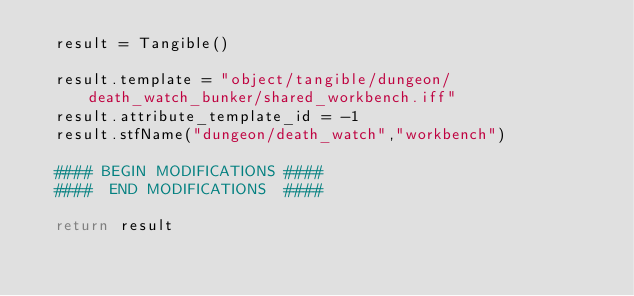<code> <loc_0><loc_0><loc_500><loc_500><_Python_>	result = Tangible()

	result.template = "object/tangible/dungeon/death_watch_bunker/shared_workbench.iff"
	result.attribute_template_id = -1
	result.stfName("dungeon/death_watch","workbench")		
	
	#### BEGIN MODIFICATIONS ####
	####  END MODIFICATIONS  ####
	
	return result</code> 